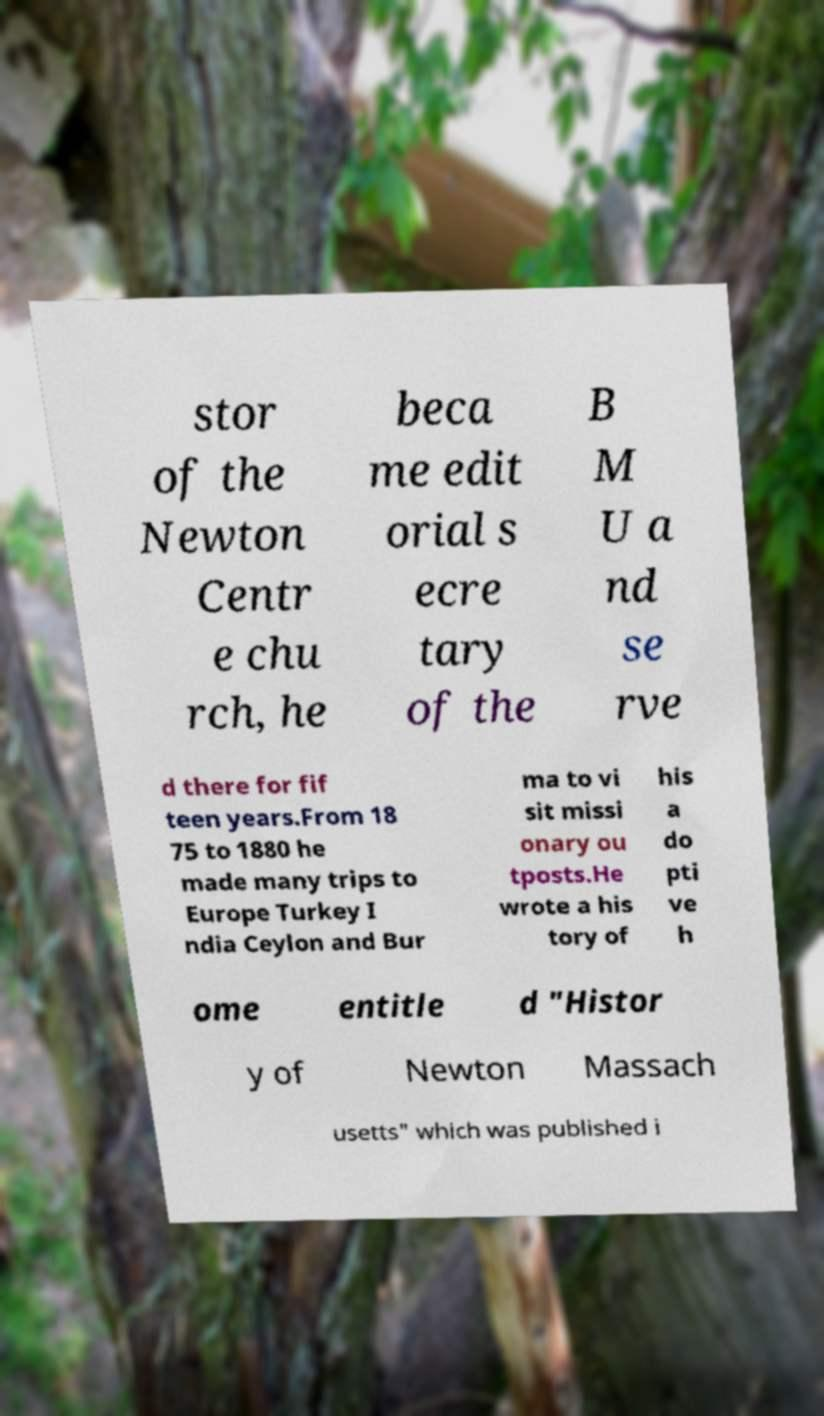There's text embedded in this image that I need extracted. Can you transcribe it verbatim? stor of the Newton Centr e chu rch, he beca me edit orial s ecre tary of the B M U a nd se rve d there for fif teen years.From 18 75 to 1880 he made many trips to Europe Turkey I ndia Ceylon and Bur ma to vi sit missi onary ou tposts.He wrote a his tory of his a do pti ve h ome entitle d "Histor y of Newton Massach usetts" which was published i 